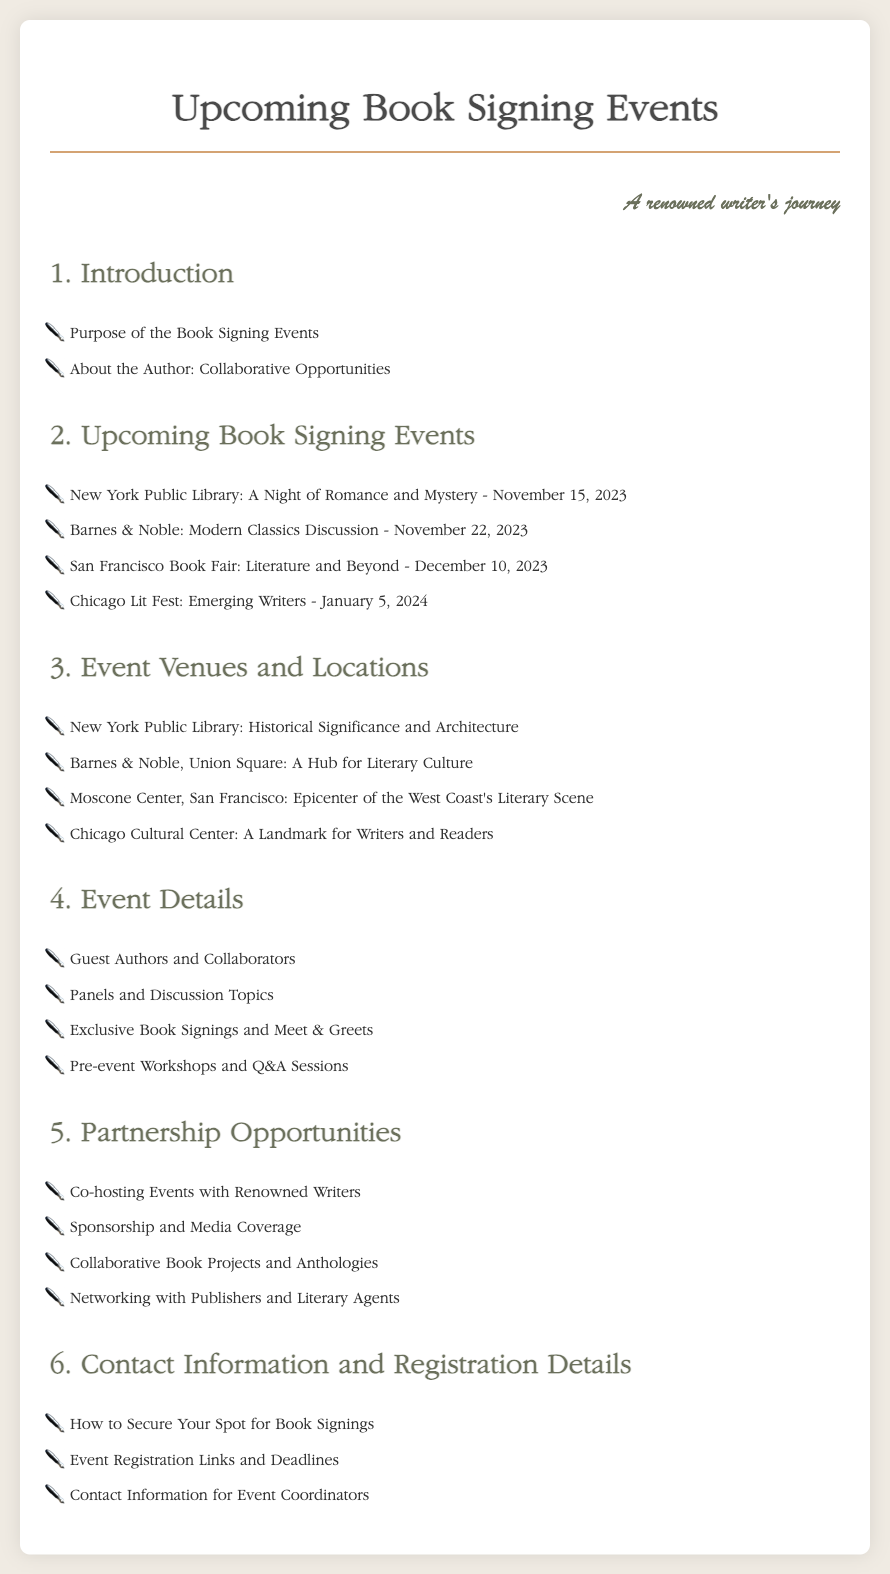What is the first event listed? The first event in the list is titled "A Night of Romance and Mystery" at the New York Public Library, scheduled for November 15, 2023.
Answer: A Night of Romance and Mystery How many events are listed in total? The document lists a total of four upcoming book signing events.
Answer: 4 What is the date of the Chicago Lit Fest event? The Chicago Lit Fest is scheduled for January 5, 2024, according to the event list.
Answer: January 5, 2024 Which location is described as "A Hub for Literary Culture"? The document refers to Barnes & Noble, Union Square, as "A Hub for Literary Culture".
Answer: Barnes & Noble, Union Square What topic is mentioned for pre-event workshops? The document includes "Q&A Sessions" as an example of topics for pre-event workshops in the event details section.
Answer: Q&A Sessions Name one type of partnership opportunity mentioned. The document lists "Co-hosting Events with Renowned Writers" as one of the partnership opportunities.
Answer: Co-hosting Events with Renowned Writers Where will the San Francisco Book Fair be held? The San Francisco Book Fair is held at the Moscone Center, as specified in the venues section.
Answer: Moscone Center What is the primary purpose of the book signing events mentioned in the introduction? The purpose of the book signing events is primarily outlined in the introduction section, though the specific wording is not given in the question.
Answer: Purpose of the Book Signing Events 